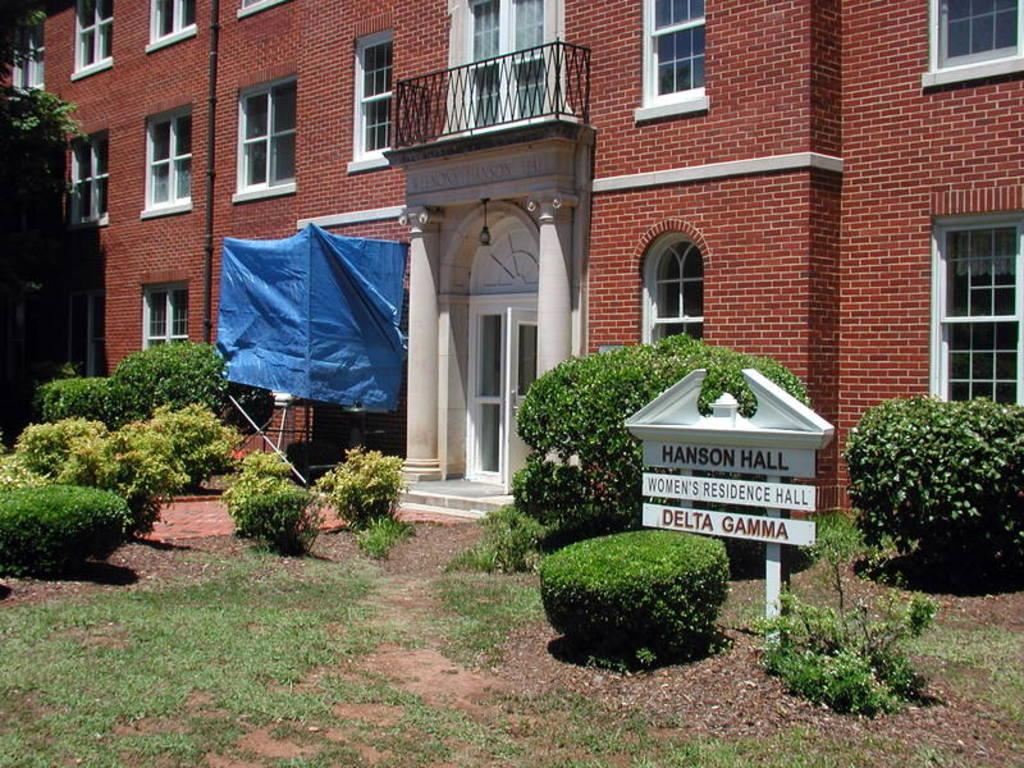What type of structure is visible in the image? There is a building in the image. What features can be seen on the building? The building has windows and a door. What other objects are present in the image? There is a pipe, a plastic sheet, plants, trees, grass, and a board with text in the image. What type of government is depicted on the board with text in the image? There is no indication of a government or any political content on the board with text in the image. Can you see a cannon in the image? There is no cannon present in the image. Is there a frog in the image? There is no frog present in the image. 